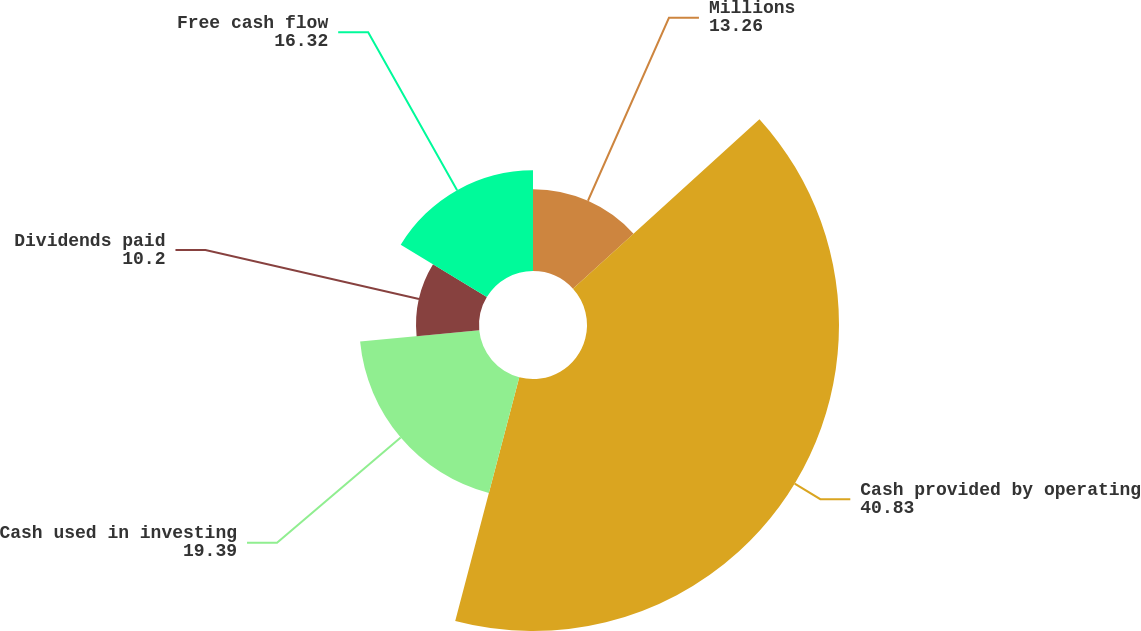Convert chart to OTSL. <chart><loc_0><loc_0><loc_500><loc_500><pie_chart><fcel>Millions<fcel>Cash provided by operating<fcel>Cash used in investing<fcel>Dividends paid<fcel>Free cash flow<nl><fcel>13.26%<fcel>40.83%<fcel>19.39%<fcel>10.2%<fcel>16.32%<nl></chart> 